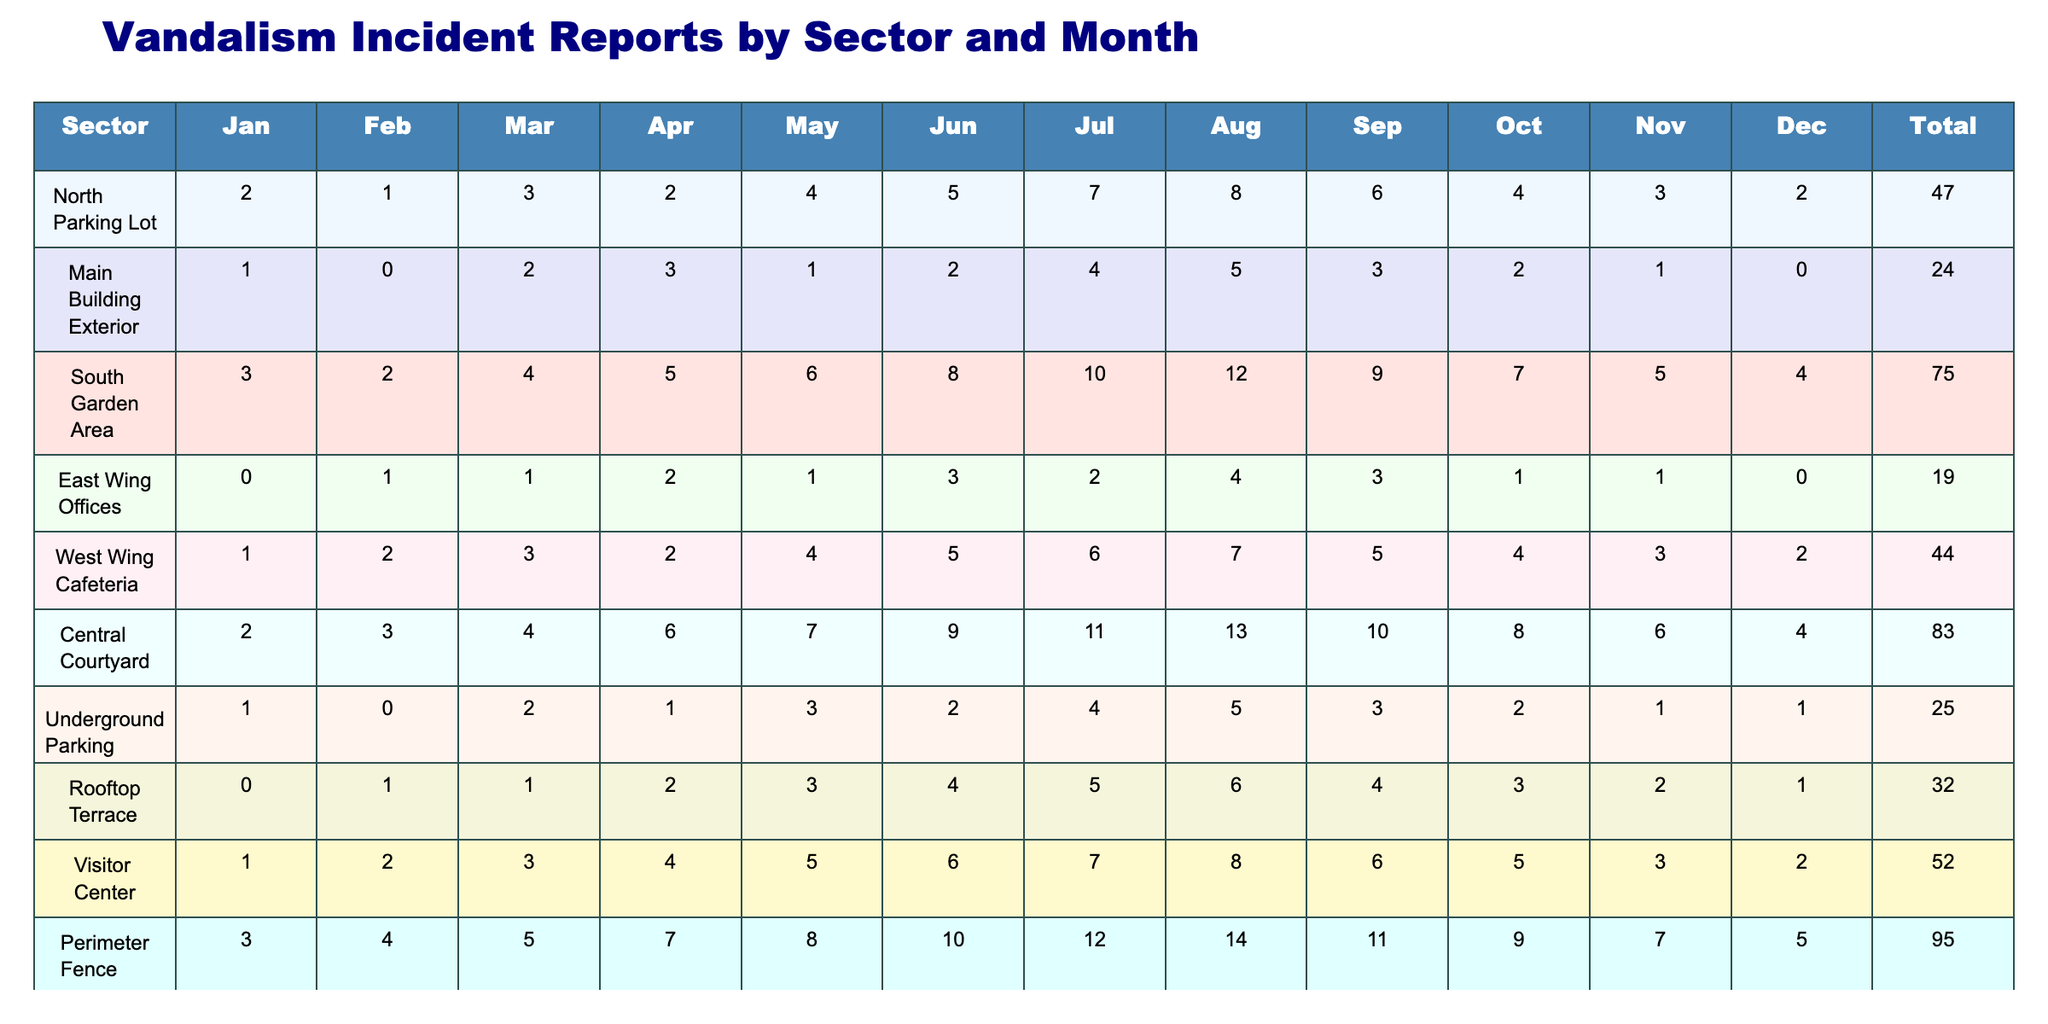What sector had the highest total number of vandalism incidents? By looking at the "Total" column at the right end of the table, we can identify the sector with the highest total. In this case, the "South Garden Area" has the highest total of 64 incidents.
Answer: South Garden Area How many incidents were reported in the Central Courtyard in August? Referring to the table, we check the value listed under the Central Courtyard for August, which is 13 incidents.
Answer: 13 Which month had the highest number of vandalism incidents in the East Wing Offices? We check all the values in the East Wing Offices row from January to December. The highest number appears in June with 3 incidents.
Answer: June What was the total number of vandalism incidents in the Perimeter Fence for the entire year? Looking at the Perimeter Fence row, we sum up all the values from January to December. The total is (3 + 4 + 5 + 7 + 8 + 10 + 12 + 14 + 11 + 9 + 7 + 5) = 64.
Answer: 64 Was there an increase in incidents from July to August in the Underground Parking? We compare the values of July (4 incidents) and August (5 incidents). Since August has more incidents than July, there is an increase.
Answer: Yes What is the average number of incidents reported in the Main Building Exterior over the year? We sum the incidents for the Main Building Exterior for the months January through December, which totals 2 (1+0+2+3+1+2+4+5+3+2+1+0) = 24. Dividing this by 12 gives an average of 2.
Answer: 2 Which sector experienced the most fluctuation in the number of incidents throughout the year? To assess fluctuation, we look at the difference between the maximum and minimum incidents for each sector. Calculating these reveals that "Central Courtyard" has values ranging from 4 to 13, showing a fluctuation of 9 incidents, which is the highest among sectors.
Answer: Central Courtyard Did the Visitor Center ever report less than 3 incidents in a month? Checking the Visitor Center row, we notice that the incidents in December (2) are less than 3. Therefore, the answer is yes.
Answer: Yes How many more incidents were reported in September compared to November in the North Parking Lot? We compare the values for September (6 incidents) and November (3 incidents) in the North Parking Lot. The difference is 6 - 3, which shows 3 more incidents in September.
Answer: 3 What sector had the least number of total incidents over the year? By checking the totals for all sectors, the "East Wing Offices" has the least with a total of 18 incidents.
Answer: East Wing Offices 